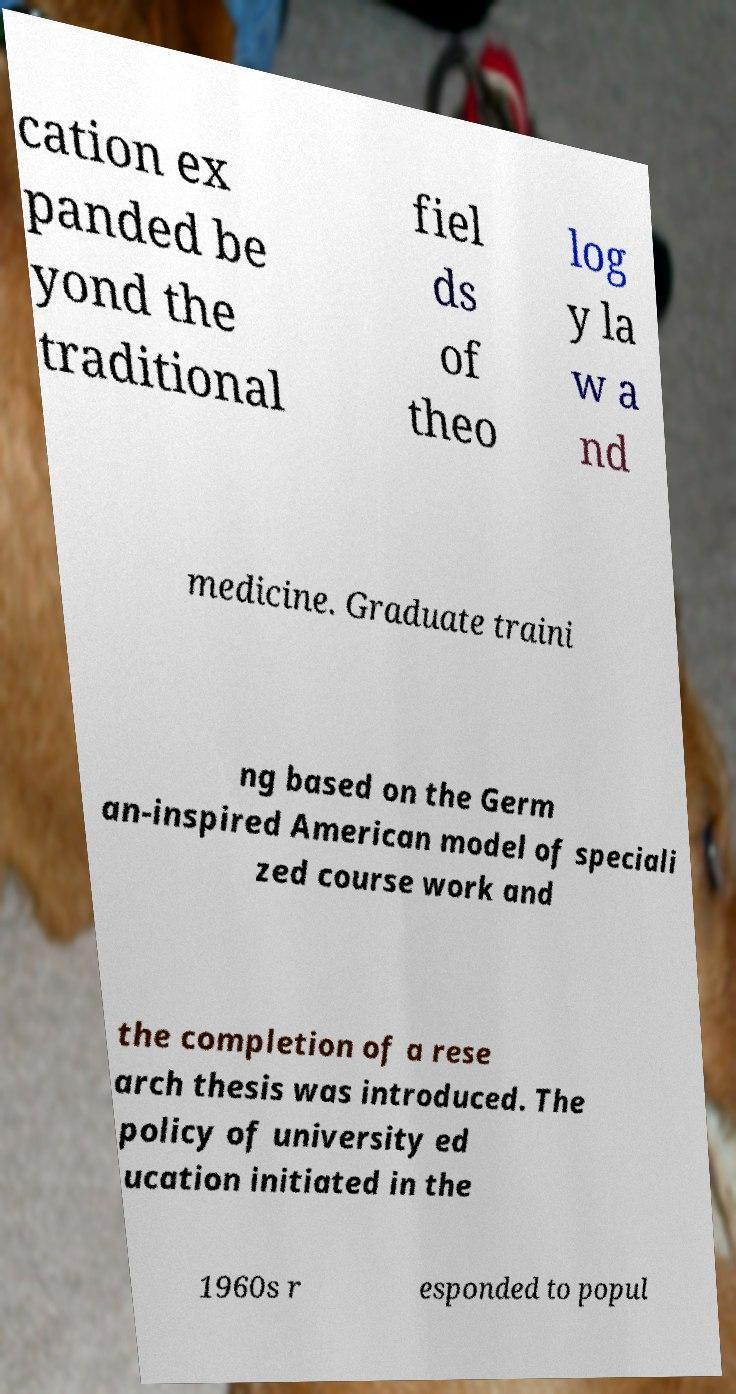There's text embedded in this image that I need extracted. Can you transcribe it verbatim? cation ex panded be yond the traditional fiel ds of theo log y la w a nd medicine. Graduate traini ng based on the Germ an-inspired American model of speciali zed course work and the completion of a rese arch thesis was introduced. The policy of university ed ucation initiated in the 1960s r esponded to popul 